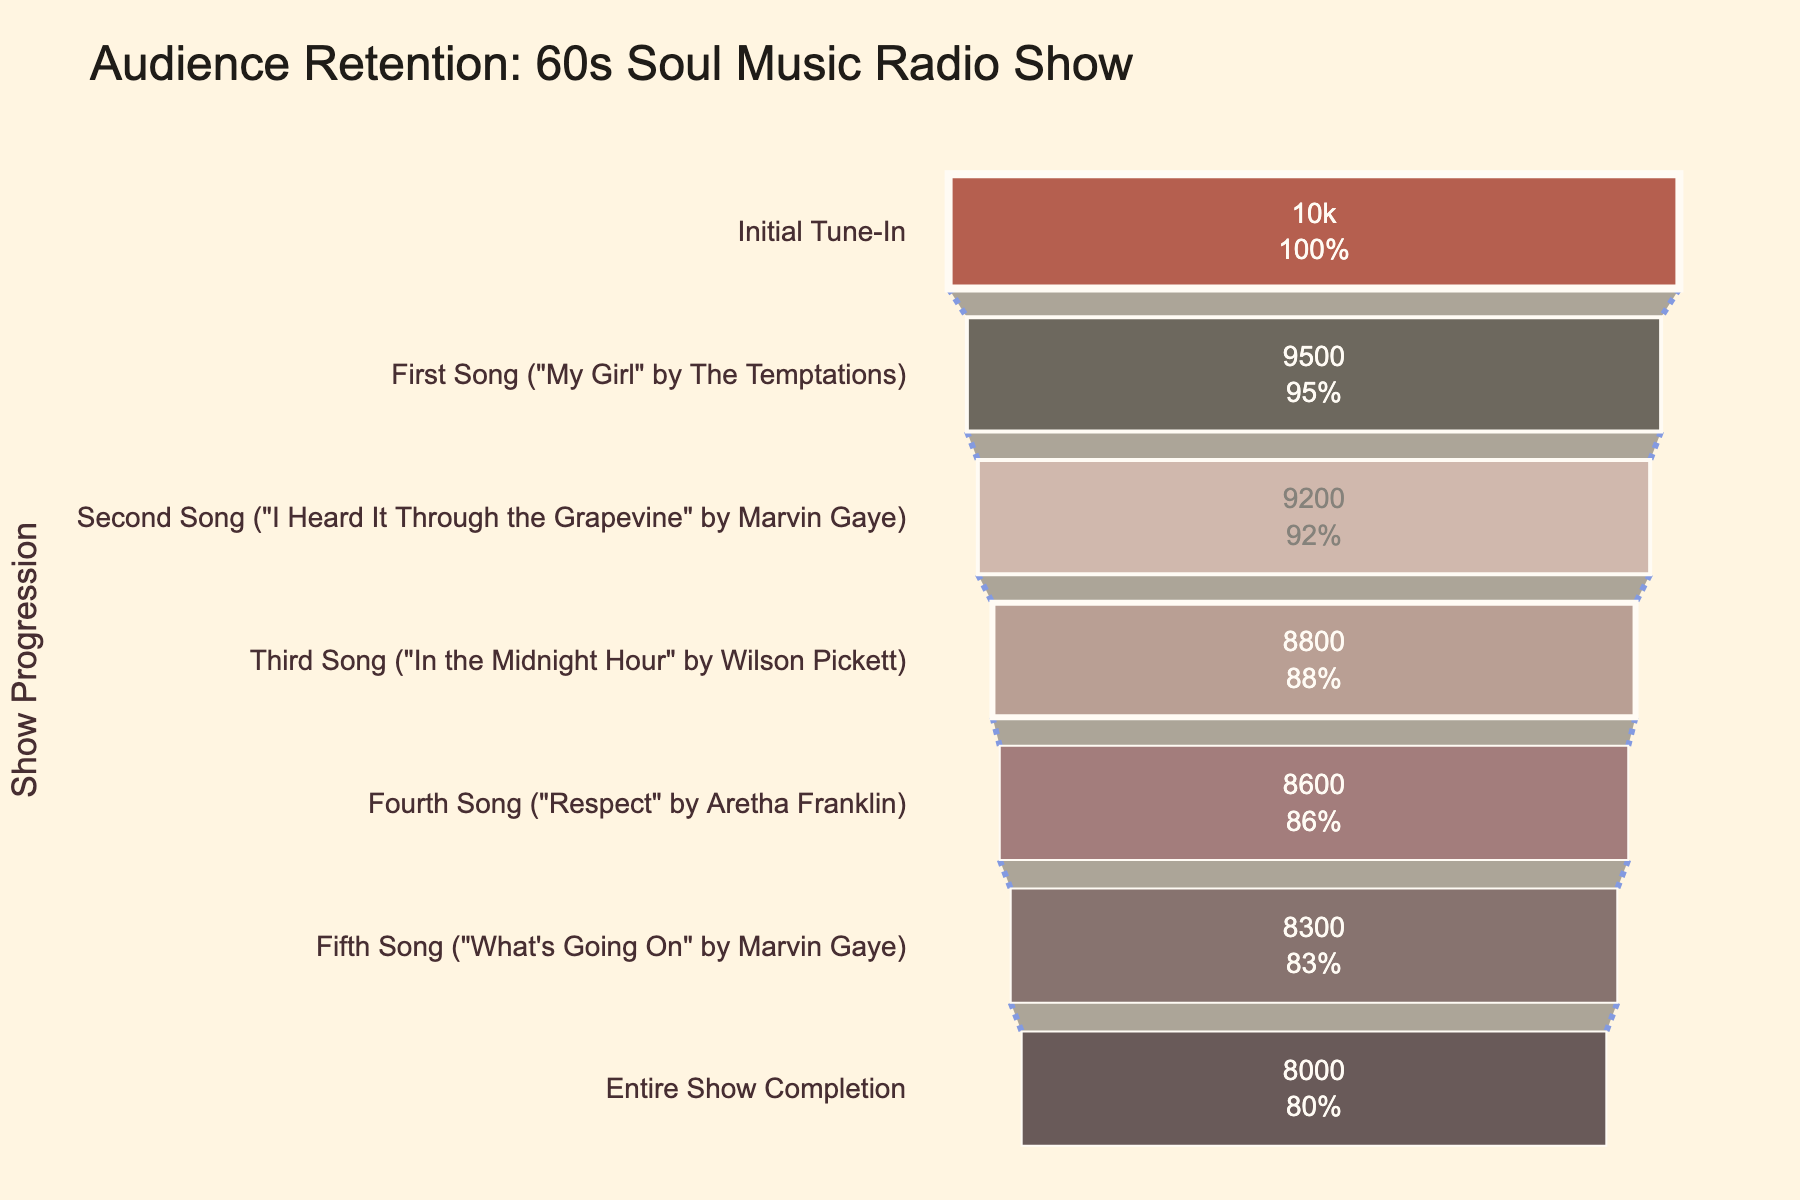What is the title of the funnel chart? The title of the funnel chart is displayed at the top of the figure. It is written in a large font.
Answer: Audience Retention: 60s Soul Music Radio Show How many stages are there in the funnel chart? To determine the number of stages, count the number of unique labels on the y-axis of the funnel chart. There are multiple stages, each representing a different step in the radio show.
Answer: 7 What is the number of listeners at the 'First Song' stage? Refer to the stage labeled 'First Song' on the y-axis, and check the corresponding value inside the funnel for the number of listeners.
Answer: 9500 Which song had the highest drop in the number of listeners from the previous stage? To find out the highest drop, compare the difference in the number of listeners between consecutive stages. Calculate the drop for each song and determine the one with the highest decrease in listeners.
Answer: Third Song ("In the Midnight Hour" by Wilson Pickett) What is the percentage of listeners retained till the end of the show? Find the number of listeners at the 'Entire Show Completion' stage and divide it by the number of initial listeners. Convert this to a percentage.
Answer: 80% Is there any stage where the number of listeners increased compared to the previous stage? Compare the number of listeners at each stage to the previous stage. Check for any stage where the number of listeners is higher than the previous stage.
Answer: No What percentage of the initial listeners tuned out by the time 'What's Going On' by Marvin Gaye was played? Look at the 'Fifth Song' stage for the number of listeners, subtract it from the initial listeners, and divide by the initial number. Convert this to a percentage.
Answer: 17% How many listeners were lost between 'My Girl' and 'Respect'? Find the number of listeners at 'First Song' (My Girl) and 'Fourth Song' (Respect) stages. Subtract the listeners at 'Respect' from those at 'My Girl'.
Answer: 900 listeners What's the color of the funnel segment for 'I Heard It Through the Grapevine'? Find the funnel segment corresponding to 'I Heard It Through the Grapevine' on the y-axis and identify its color.
Answer: #1F1C18 (dark gray) Compare the retention rate between 'Third Song' and 'Fourth Song'. Calculate the percentage of listeners retained at 'Third Song' and 'Fourth Song' by dividing the number of listeners at each stage by the initial listeners. Then compare these percentages.
Answer: Third Song: 88%, Fourth Song: 86% 